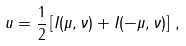<formula> <loc_0><loc_0><loc_500><loc_500>\ u = \frac { 1 } { 2 } \left [ I ( \mu , \nu ) + I ( - \mu , \nu ) \right ] \, ,</formula> 